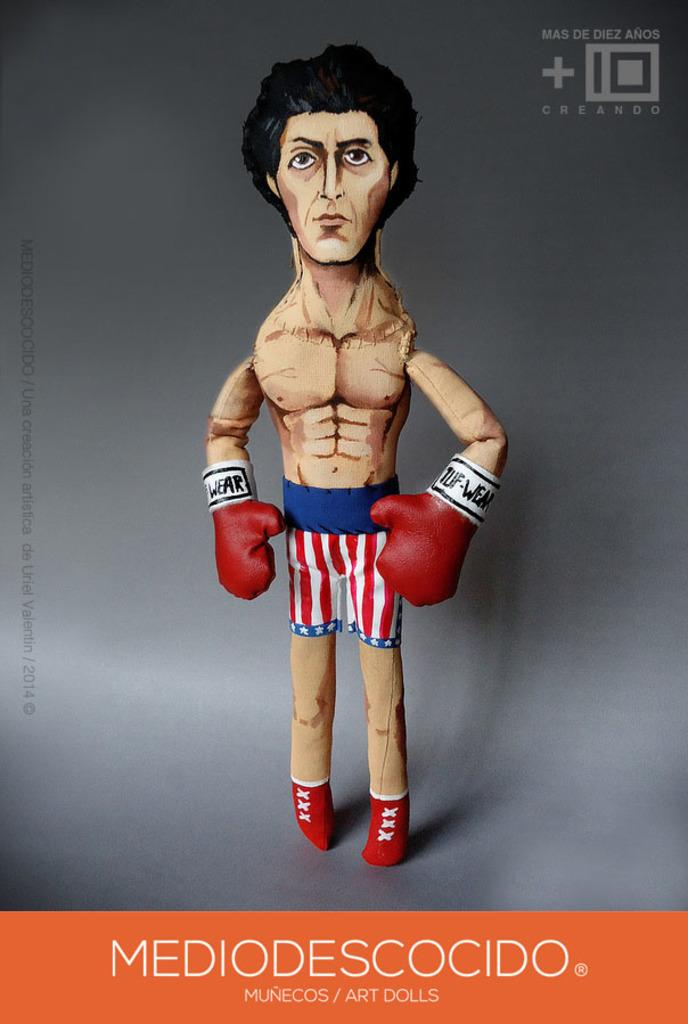Provide a one-sentence caption for the provided image. Poster of a boxer with MEDIODESCOCIDO in white letters at the bottom. 